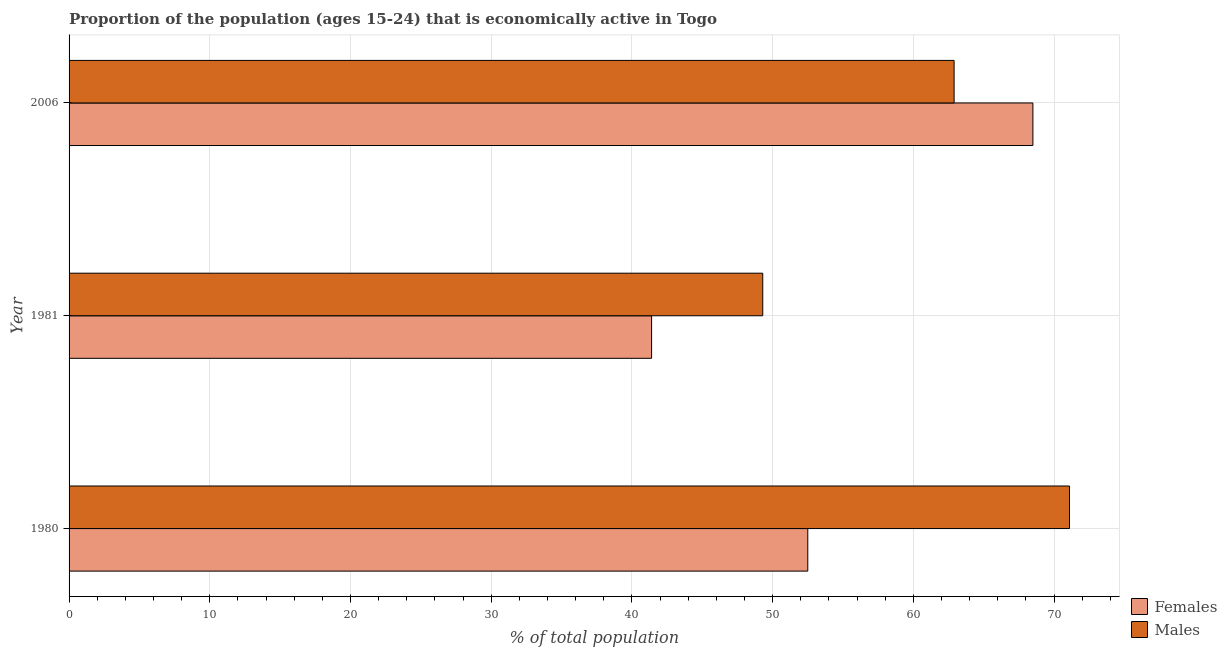Are the number of bars per tick equal to the number of legend labels?
Make the answer very short. Yes. How many bars are there on the 3rd tick from the bottom?
Your answer should be very brief. 2. What is the label of the 2nd group of bars from the top?
Your answer should be compact. 1981. In how many cases, is the number of bars for a given year not equal to the number of legend labels?
Your response must be concise. 0. What is the percentage of economically active female population in 1981?
Make the answer very short. 41.4. Across all years, what is the maximum percentage of economically active male population?
Make the answer very short. 71.1. Across all years, what is the minimum percentage of economically active male population?
Your answer should be compact. 49.3. What is the total percentage of economically active male population in the graph?
Your answer should be compact. 183.3. What is the difference between the percentage of economically active male population in 1981 and that in 2006?
Give a very brief answer. -13.6. What is the difference between the percentage of economically active female population in 1981 and the percentage of economically active male population in 1980?
Provide a short and direct response. -29.7. What is the average percentage of economically active female population per year?
Provide a succinct answer. 54.13. In how many years, is the percentage of economically active male population greater than 8 %?
Your answer should be compact. 3. What is the ratio of the percentage of economically active female population in 1981 to that in 2006?
Give a very brief answer. 0.6. Is the difference between the percentage of economically active female population in 1980 and 1981 greater than the difference between the percentage of economically active male population in 1980 and 1981?
Keep it short and to the point. No. What is the difference between the highest and the lowest percentage of economically active male population?
Your answer should be compact. 21.8. What does the 2nd bar from the top in 1980 represents?
Offer a very short reply. Females. What does the 2nd bar from the bottom in 2006 represents?
Keep it short and to the point. Males. Does the graph contain grids?
Ensure brevity in your answer.  Yes. How are the legend labels stacked?
Keep it short and to the point. Vertical. What is the title of the graph?
Your answer should be compact. Proportion of the population (ages 15-24) that is economically active in Togo. Does "Manufacturing industries and construction" appear as one of the legend labels in the graph?
Provide a succinct answer. No. What is the label or title of the X-axis?
Provide a short and direct response. % of total population. What is the % of total population of Females in 1980?
Give a very brief answer. 52.5. What is the % of total population in Males in 1980?
Your answer should be very brief. 71.1. What is the % of total population of Females in 1981?
Provide a short and direct response. 41.4. What is the % of total population in Males in 1981?
Provide a short and direct response. 49.3. What is the % of total population of Females in 2006?
Ensure brevity in your answer.  68.5. What is the % of total population of Males in 2006?
Your answer should be compact. 62.9. Across all years, what is the maximum % of total population of Females?
Provide a short and direct response. 68.5. Across all years, what is the maximum % of total population in Males?
Keep it short and to the point. 71.1. Across all years, what is the minimum % of total population in Females?
Provide a succinct answer. 41.4. Across all years, what is the minimum % of total population in Males?
Provide a short and direct response. 49.3. What is the total % of total population in Females in the graph?
Offer a terse response. 162.4. What is the total % of total population of Males in the graph?
Offer a very short reply. 183.3. What is the difference between the % of total population in Females in 1980 and that in 1981?
Offer a very short reply. 11.1. What is the difference between the % of total population in Males in 1980 and that in 1981?
Your answer should be compact. 21.8. What is the difference between the % of total population in Females in 1980 and that in 2006?
Provide a short and direct response. -16. What is the difference between the % of total population in Males in 1980 and that in 2006?
Offer a very short reply. 8.2. What is the difference between the % of total population of Females in 1981 and that in 2006?
Your answer should be compact. -27.1. What is the difference between the % of total population in Females in 1980 and the % of total population in Males in 1981?
Make the answer very short. 3.2. What is the difference between the % of total population of Females in 1981 and the % of total population of Males in 2006?
Your response must be concise. -21.5. What is the average % of total population in Females per year?
Keep it short and to the point. 54.13. What is the average % of total population of Males per year?
Offer a very short reply. 61.1. In the year 1980, what is the difference between the % of total population of Females and % of total population of Males?
Give a very brief answer. -18.6. In the year 1981, what is the difference between the % of total population in Females and % of total population in Males?
Give a very brief answer. -7.9. In the year 2006, what is the difference between the % of total population of Females and % of total population of Males?
Provide a short and direct response. 5.6. What is the ratio of the % of total population of Females in 1980 to that in 1981?
Make the answer very short. 1.27. What is the ratio of the % of total population in Males in 1980 to that in 1981?
Ensure brevity in your answer.  1.44. What is the ratio of the % of total population of Females in 1980 to that in 2006?
Provide a short and direct response. 0.77. What is the ratio of the % of total population of Males in 1980 to that in 2006?
Your answer should be very brief. 1.13. What is the ratio of the % of total population in Females in 1981 to that in 2006?
Provide a succinct answer. 0.6. What is the ratio of the % of total population in Males in 1981 to that in 2006?
Provide a short and direct response. 0.78. What is the difference between the highest and the lowest % of total population of Females?
Ensure brevity in your answer.  27.1. What is the difference between the highest and the lowest % of total population in Males?
Provide a succinct answer. 21.8. 